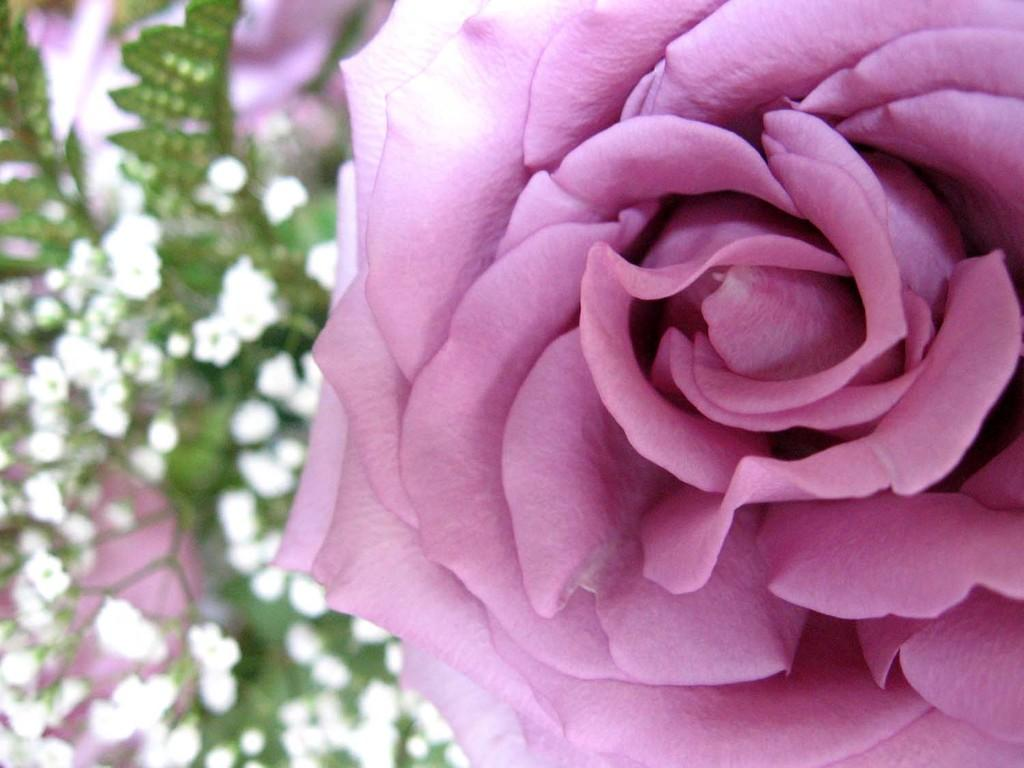What type of plant is featured in the image? There is a flower in the image, which suggests that the plant is a flowering plant. What color is the main flower in the image? The main flower in the image is pink. Are there any other colors of flowers on the same plant? Yes, there are white flowers on the same plant as the pink flower. Can you hear the bells ringing in the image? There are no bells present in the image, so it is not possible to hear them ringing. 